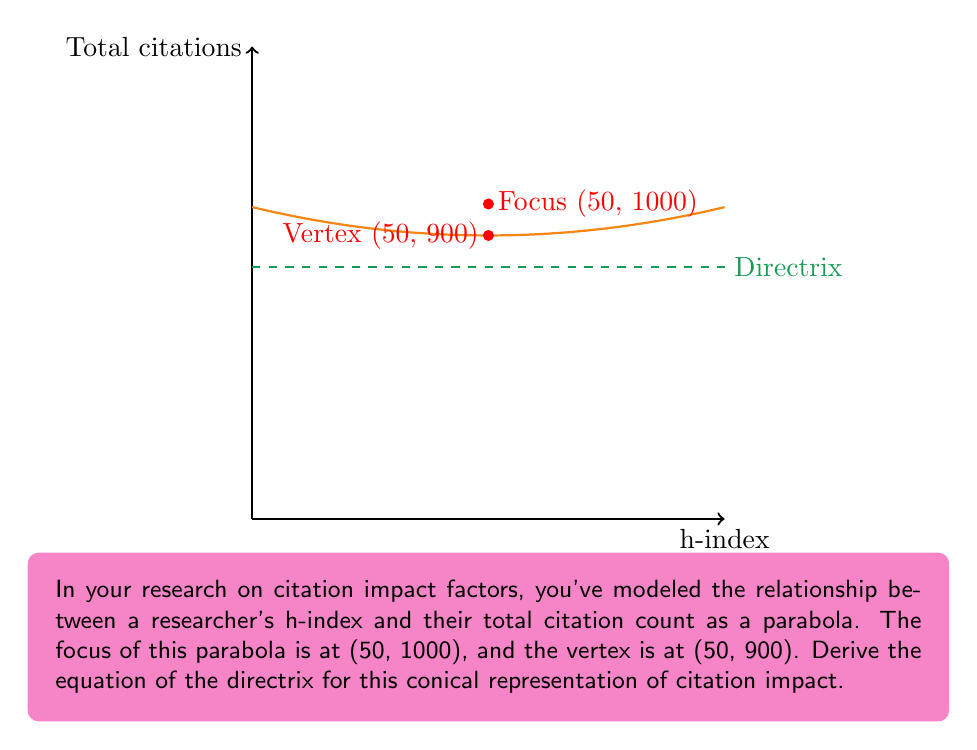What is the answer to this math problem? Let's approach this step-by-step:

1) For a parabola with a vertical axis of symmetry, the general form of the equation is:
   $$(y - k) = 4p(x - h)^2$$
   where (h, k) is the vertex and p is the distance from the vertex to the focus.

2) We're given that the vertex is at (50, 900) and the focus is at (50, 1000).

3) The distance p is half the distance between the focus and the vertex:
   $$p = \frac{1000 - 900}{2} = 50$$

4) Now we can write the equation of the parabola:
   $$(y - 900) = 4(50)(x - 50)^2$$

5) For a parabola with a vertical axis of symmetry, the directrix is a horizontal line.

6) The distance from the vertex to the directrix is equal to the distance from the vertex to the focus.

7) Since the focus is 100 units above the vertex, the directrix must be 100 units below the vertex.

8) The y-coordinate of the vertex is 900, so the y-coordinate of the directrix is:
   $$900 - 100 = 800$$

9) Therefore, the equation of the directrix is:
   $$y = 800$$
Answer: $y = 800$ 